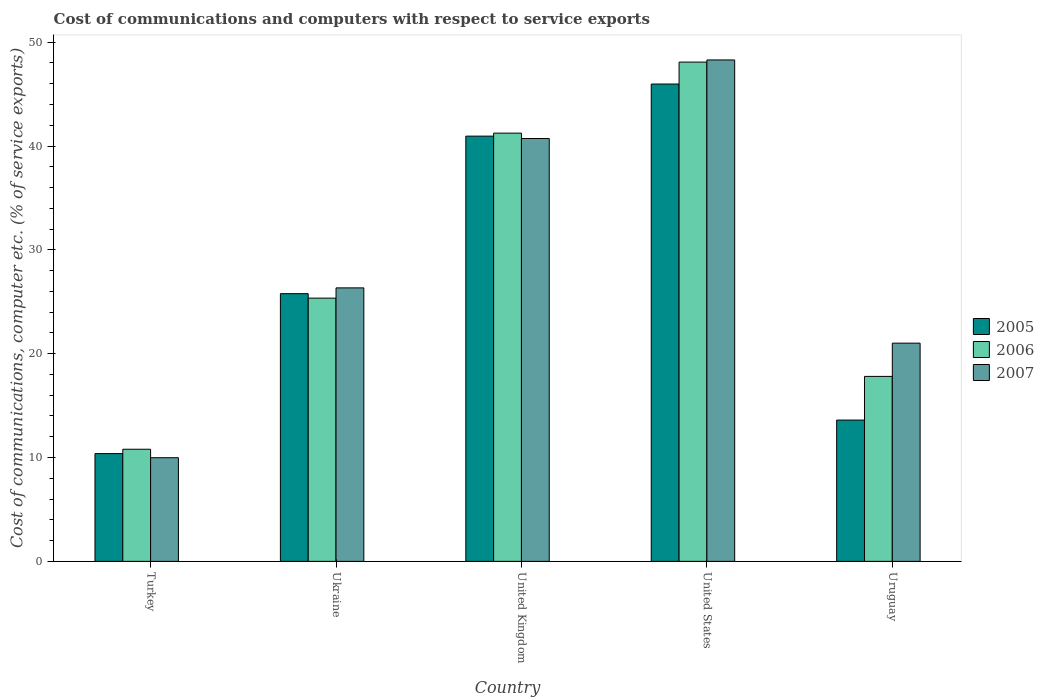How many different coloured bars are there?
Your answer should be very brief. 3. Are the number of bars per tick equal to the number of legend labels?
Your answer should be compact. Yes. How many bars are there on the 5th tick from the right?
Your answer should be compact. 3. What is the label of the 2nd group of bars from the left?
Make the answer very short. Ukraine. What is the cost of communications and computers in 2005 in Turkey?
Your answer should be compact. 10.38. Across all countries, what is the maximum cost of communications and computers in 2007?
Your answer should be very brief. 48.29. Across all countries, what is the minimum cost of communications and computers in 2007?
Offer a very short reply. 9.98. In which country was the cost of communications and computers in 2007 maximum?
Keep it short and to the point. United States. What is the total cost of communications and computers in 2006 in the graph?
Your answer should be very brief. 143.29. What is the difference between the cost of communications and computers in 2005 in Turkey and that in Ukraine?
Offer a very short reply. -15.4. What is the difference between the cost of communications and computers in 2005 in United Kingdom and the cost of communications and computers in 2006 in Uruguay?
Offer a terse response. 23.14. What is the average cost of communications and computers in 2005 per country?
Your answer should be compact. 27.34. What is the difference between the cost of communications and computers of/in 2006 and cost of communications and computers of/in 2007 in Ukraine?
Keep it short and to the point. -0.99. In how many countries, is the cost of communications and computers in 2006 greater than 12 %?
Your answer should be very brief. 4. What is the ratio of the cost of communications and computers in 2007 in Ukraine to that in Uruguay?
Keep it short and to the point. 1.25. Is the cost of communications and computers in 2005 in Turkey less than that in United Kingdom?
Give a very brief answer. Yes. What is the difference between the highest and the second highest cost of communications and computers in 2005?
Offer a very short reply. 15.17. What is the difference between the highest and the lowest cost of communications and computers in 2006?
Provide a short and direct response. 37.29. Are all the bars in the graph horizontal?
Your response must be concise. No. Are the values on the major ticks of Y-axis written in scientific E-notation?
Provide a short and direct response. No. Does the graph contain grids?
Your response must be concise. No. Where does the legend appear in the graph?
Make the answer very short. Center right. How many legend labels are there?
Make the answer very short. 3. How are the legend labels stacked?
Offer a terse response. Vertical. What is the title of the graph?
Ensure brevity in your answer.  Cost of communications and computers with respect to service exports. Does "1963" appear as one of the legend labels in the graph?
Your answer should be very brief. No. What is the label or title of the X-axis?
Provide a short and direct response. Country. What is the label or title of the Y-axis?
Your response must be concise. Cost of communications, computer etc. (% of service exports). What is the Cost of communications, computer etc. (% of service exports) in 2005 in Turkey?
Your response must be concise. 10.38. What is the Cost of communications, computer etc. (% of service exports) in 2006 in Turkey?
Offer a terse response. 10.8. What is the Cost of communications, computer etc. (% of service exports) of 2007 in Turkey?
Ensure brevity in your answer.  9.98. What is the Cost of communications, computer etc. (% of service exports) of 2005 in Ukraine?
Give a very brief answer. 25.78. What is the Cost of communications, computer etc. (% of service exports) in 2006 in Ukraine?
Give a very brief answer. 25.35. What is the Cost of communications, computer etc. (% of service exports) of 2007 in Ukraine?
Ensure brevity in your answer.  26.34. What is the Cost of communications, computer etc. (% of service exports) in 2005 in United Kingdom?
Provide a succinct answer. 40.95. What is the Cost of communications, computer etc. (% of service exports) in 2006 in United Kingdom?
Your answer should be compact. 41.24. What is the Cost of communications, computer etc. (% of service exports) of 2007 in United Kingdom?
Offer a terse response. 40.72. What is the Cost of communications, computer etc. (% of service exports) in 2005 in United States?
Offer a terse response. 45.97. What is the Cost of communications, computer etc. (% of service exports) of 2006 in United States?
Give a very brief answer. 48.08. What is the Cost of communications, computer etc. (% of service exports) of 2007 in United States?
Provide a succinct answer. 48.29. What is the Cost of communications, computer etc. (% of service exports) in 2005 in Uruguay?
Your answer should be very brief. 13.61. What is the Cost of communications, computer etc. (% of service exports) of 2006 in Uruguay?
Make the answer very short. 17.81. What is the Cost of communications, computer etc. (% of service exports) in 2007 in Uruguay?
Your response must be concise. 21.01. Across all countries, what is the maximum Cost of communications, computer etc. (% of service exports) in 2005?
Make the answer very short. 45.97. Across all countries, what is the maximum Cost of communications, computer etc. (% of service exports) in 2006?
Provide a succinct answer. 48.08. Across all countries, what is the maximum Cost of communications, computer etc. (% of service exports) in 2007?
Your answer should be compact. 48.29. Across all countries, what is the minimum Cost of communications, computer etc. (% of service exports) of 2005?
Your answer should be very brief. 10.38. Across all countries, what is the minimum Cost of communications, computer etc. (% of service exports) in 2006?
Give a very brief answer. 10.8. Across all countries, what is the minimum Cost of communications, computer etc. (% of service exports) in 2007?
Keep it short and to the point. 9.98. What is the total Cost of communications, computer etc. (% of service exports) in 2005 in the graph?
Your response must be concise. 136.69. What is the total Cost of communications, computer etc. (% of service exports) in 2006 in the graph?
Your answer should be very brief. 143.29. What is the total Cost of communications, computer etc. (% of service exports) in 2007 in the graph?
Your answer should be very brief. 146.35. What is the difference between the Cost of communications, computer etc. (% of service exports) in 2005 in Turkey and that in Ukraine?
Keep it short and to the point. -15.4. What is the difference between the Cost of communications, computer etc. (% of service exports) in 2006 in Turkey and that in Ukraine?
Offer a terse response. -14.55. What is the difference between the Cost of communications, computer etc. (% of service exports) of 2007 in Turkey and that in Ukraine?
Offer a very short reply. -16.36. What is the difference between the Cost of communications, computer etc. (% of service exports) of 2005 in Turkey and that in United Kingdom?
Your answer should be compact. -30.58. What is the difference between the Cost of communications, computer etc. (% of service exports) of 2006 in Turkey and that in United Kingdom?
Provide a succinct answer. -30.44. What is the difference between the Cost of communications, computer etc. (% of service exports) in 2007 in Turkey and that in United Kingdom?
Make the answer very short. -30.74. What is the difference between the Cost of communications, computer etc. (% of service exports) of 2005 in Turkey and that in United States?
Provide a short and direct response. -35.59. What is the difference between the Cost of communications, computer etc. (% of service exports) of 2006 in Turkey and that in United States?
Your answer should be very brief. -37.29. What is the difference between the Cost of communications, computer etc. (% of service exports) of 2007 in Turkey and that in United States?
Your answer should be very brief. -38.31. What is the difference between the Cost of communications, computer etc. (% of service exports) in 2005 in Turkey and that in Uruguay?
Your response must be concise. -3.23. What is the difference between the Cost of communications, computer etc. (% of service exports) of 2006 in Turkey and that in Uruguay?
Offer a terse response. -7.02. What is the difference between the Cost of communications, computer etc. (% of service exports) of 2007 in Turkey and that in Uruguay?
Keep it short and to the point. -11.03. What is the difference between the Cost of communications, computer etc. (% of service exports) in 2005 in Ukraine and that in United Kingdom?
Your answer should be compact. -15.17. What is the difference between the Cost of communications, computer etc. (% of service exports) of 2006 in Ukraine and that in United Kingdom?
Offer a very short reply. -15.89. What is the difference between the Cost of communications, computer etc. (% of service exports) of 2007 in Ukraine and that in United Kingdom?
Your answer should be very brief. -14.39. What is the difference between the Cost of communications, computer etc. (% of service exports) of 2005 in Ukraine and that in United States?
Your response must be concise. -20.19. What is the difference between the Cost of communications, computer etc. (% of service exports) in 2006 in Ukraine and that in United States?
Your answer should be very brief. -22.73. What is the difference between the Cost of communications, computer etc. (% of service exports) in 2007 in Ukraine and that in United States?
Your response must be concise. -21.95. What is the difference between the Cost of communications, computer etc. (% of service exports) in 2005 in Ukraine and that in Uruguay?
Your response must be concise. 12.17. What is the difference between the Cost of communications, computer etc. (% of service exports) in 2006 in Ukraine and that in Uruguay?
Give a very brief answer. 7.54. What is the difference between the Cost of communications, computer etc. (% of service exports) of 2007 in Ukraine and that in Uruguay?
Offer a terse response. 5.32. What is the difference between the Cost of communications, computer etc. (% of service exports) of 2005 in United Kingdom and that in United States?
Provide a short and direct response. -5.02. What is the difference between the Cost of communications, computer etc. (% of service exports) in 2006 in United Kingdom and that in United States?
Provide a succinct answer. -6.84. What is the difference between the Cost of communications, computer etc. (% of service exports) in 2007 in United Kingdom and that in United States?
Provide a short and direct response. -7.57. What is the difference between the Cost of communications, computer etc. (% of service exports) in 2005 in United Kingdom and that in Uruguay?
Your response must be concise. 27.34. What is the difference between the Cost of communications, computer etc. (% of service exports) in 2006 in United Kingdom and that in Uruguay?
Give a very brief answer. 23.43. What is the difference between the Cost of communications, computer etc. (% of service exports) of 2007 in United Kingdom and that in Uruguay?
Your response must be concise. 19.71. What is the difference between the Cost of communications, computer etc. (% of service exports) in 2005 in United States and that in Uruguay?
Your answer should be very brief. 32.36. What is the difference between the Cost of communications, computer etc. (% of service exports) of 2006 in United States and that in Uruguay?
Your answer should be very brief. 30.27. What is the difference between the Cost of communications, computer etc. (% of service exports) of 2007 in United States and that in Uruguay?
Give a very brief answer. 27.27. What is the difference between the Cost of communications, computer etc. (% of service exports) in 2005 in Turkey and the Cost of communications, computer etc. (% of service exports) in 2006 in Ukraine?
Offer a very short reply. -14.97. What is the difference between the Cost of communications, computer etc. (% of service exports) of 2005 in Turkey and the Cost of communications, computer etc. (% of service exports) of 2007 in Ukraine?
Offer a terse response. -15.96. What is the difference between the Cost of communications, computer etc. (% of service exports) of 2006 in Turkey and the Cost of communications, computer etc. (% of service exports) of 2007 in Ukraine?
Provide a succinct answer. -15.54. What is the difference between the Cost of communications, computer etc. (% of service exports) in 2005 in Turkey and the Cost of communications, computer etc. (% of service exports) in 2006 in United Kingdom?
Keep it short and to the point. -30.86. What is the difference between the Cost of communications, computer etc. (% of service exports) in 2005 in Turkey and the Cost of communications, computer etc. (% of service exports) in 2007 in United Kingdom?
Your response must be concise. -30.35. What is the difference between the Cost of communications, computer etc. (% of service exports) of 2006 in Turkey and the Cost of communications, computer etc. (% of service exports) of 2007 in United Kingdom?
Keep it short and to the point. -29.92. What is the difference between the Cost of communications, computer etc. (% of service exports) in 2005 in Turkey and the Cost of communications, computer etc. (% of service exports) in 2006 in United States?
Your answer should be compact. -37.71. What is the difference between the Cost of communications, computer etc. (% of service exports) in 2005 in Turkey and the Cost of communications, computer etc. (% of service exports) in 2007 in United States?
Offer a terse response. -37.91. What is the difference between the Cost of communications, computer etc. (% of service exports) in 2006 in Turkey and the Cost of communications, computer etc. (% of service exports) in 2007 in United States?
Offer a terse response. -37.49. What is the difference between the Cost of communications, computer etc. (% of service exports) in 2005 in Turkey and the Cost of communications, computer etc. (% of service exports) in 2006 in Uruguay?
Make the answer very short. -7.44. What is the difference between the Cost of communications, computer etc. (% of service exports) of 2005 in Turkey and the Cost of communications, computer etc. (% of service exports) of 2007 in Uruguay?
Ensure brevity in your answer.  -10.64. What is the difference between the Cost of communications, computer etc. (% of service exports) in 2006 in Turkey and the Cost of communications, computer etc. (% of service exports) in 2007 in Uruguay?
Offer a very short reply. -10.22. What is the difference between the Cost of communications, computer etc. (% of service exports) in 2005 in Ukraine and the Cost of communications, computer etc. (% of service exports) in 2006 in United Kingdom?
Offer a terse response. -15.46. What is the difference between the Cost of communications, computer etc. (% of service exports) in 2005 in Ukraine and the Cost of communications, computer etc. (% of service exports) in 2007 in United Kingdom?
Provide a succinct answer. -14.94. What is the difference between the Cost of communications, computer etc. (% of service exports) in 2006 in Ukraine and the Cost of communications, computer etc. (% of service exports) in 2007 in United Kingdom?
Provide a short and direct response. -15.37. What is the difference between the Cost of communications, computer etc. (% of service exports) in 2005 in Ukraine and the Cost of communications, computer etc. (% of service exports) in 2006 in United States?
Keep it short and to the point. -22.3. What is the difference between the Cost of communications, computer etc. (% of service exports) in 2005 in Ukraine and the Cost of communications, computer etc. (% of service exports) in 2007 in United States?
Ensure brevity in your answer.  -22.51. What is the difference between the Cost of communications, computer etc. (% of service exports) of 2006 in Ukraine and the Cost of communications, computer etc. (% of service exports) of 2007 in United States?
Your answer should be compact. -22.94. What is the difference between the Cost of communications, computer etc. (% of service exports) in 2005 in Ukraine and the Cost of communications, computer etc. (% of service exports) in 2006 in Uruguay?
Offer a very short reply. 7.97. What is the difference between the Cost of communications, computer etc. (% of service exports) in 2005 in Ukraine and the Cost of communications, computer etc. (% of service exports) in 2007 in Uruguay?
Give a very brief answer. 4.77. What is the difference between the Cost of communications, computer etc. (% of service exports) in 2006 in Ukraine and the Cost of communications, computer etc. (% of service exports) in 2007 in Uruguay?
Your answer should be compact. 4.34. What is the difference between the Cost of communications, computer etc. (% of service exports) of 2005 in United Kingdom and the Cost of communications, computer etc. (% of service exports) of 2006 in United States?
Provide a succinct answer. -7.13. What is the difference between the Cost of communications, computer etc. (% of service exports) of 2005 in United Kingdom and the Cost of communications, computer etc. (% of service exports) of 2007 in United States?
Give a very brief answer. -7.34. What is the difference between the Cost of communications, computer etc. (% of service exports) of 2006 in United Kingdom and the Cost of communications, computer etc. (% of service exports) of 2007 in United States?
Provide a succinct answer. -7.05. What is the difference between the Cost of communications, computer etc. (% of service exports) in 2005 in United Kingdom and the Cost of communications, computer etc. (% of service exports) in 2006 in Uruguay?
Offer a terse response. 23.14. What is the difference between the Cost of communications, computer etc. (% of service exports) in 2005 in United Kingdom and the Cost of communications, computer etc. (% of service exports) in 2007 in Uruguay?
Make the answer very short. 19.94. What is the difference between the Cost of communications, computer etc. (% of service exports) of 2006 in United Kingdom and the Cost of communications, computer etc. (% of service exports) of 2007 in Uruguay?
Keep it short and to the point. 20.23. What is the difference between the Cost of communications, computer etc. (% of service exports) of 2005 in United States and the Cost of communications, computer etc. (% of service exports) of 2006 in Uruguay?
Your response must be concise. 28.16. What is the difference between the Cost of communications, computer etc. (% of service exports) of 2005 in United States and the Cost of communications, computer etc. (% of service exports) of 2007 in Uruguay?
Your answer should be very brief. 24.96. What is the difference between the Cost of communications, computer etc. (% of service exports) of 2006 in United States and the Cost of communications, computer etc. (% of service exports) of 2007 in Uruguay?
Keep it short and to the point. 27.07. What is the average Cost of communications, computer etc. (% of service exports) in 2005 per country?
Your response must be concise. 27.34. What is the average Cost of communications, computer etc. (% of service exports) in 2006 per country?
Ensure brevity in your answer.  28.66. What is the average Cost of communications, computer etc. (% of service exports) of 2007 per country?
Your answer should be very brief. 29.27. What is the difference between the Cost of communications, computer etc. (% of service exports) of 2005 and Cost of communications, computer etc. (% of service exports) of 2006 in Turkey?
Your answer should be very brief. -0.42. What is the difference between the Cost of communications, computer etc. (% of service exports) in 2005 and Cost of communications, computer etc. (% of service exports) in 2007 in Turkey?
Ensure brevity in your answer.  0.39. What is the difference between the Cost of communications, computer etc. (% of service exports) in 2006 and Cost of communications, computer etc. (% of service exports) in 2007 in Turkey?
Make the answer very short. 0.82. What is the difference between the Cost of communications, computer etc. (% of service exports) of 2005 and Cost of communications, computer etc. (% of service exports) of 2006 in Ukraine?
Provide a succinct answer. 0.43. What is the difference between the Cost of communications, computer etc. (% of service exports) of 2005 and Cost of communications, computer etc. (% of service exports) of 2007 in Ukraine?
Ensure brevity in your answer.  -0.56. What is the difference between the Cost of communications, computer etc. (% of service exports) in 2006 and Cost of communications, computer etc. (% of service exports) in 2007 in Ukraine?
Your answer should be very brief. -0.99. What is the difference between the Cost of communications, computer etc. (% of service exports) in 2005 and Cost of communications, computer etc. (% of service exports) in 2006 in United Kingdom?
Give a very brief answer. -0.29. What is the difference between the Cost of communications, computer etc. (% of service exports) of 2005 and Cost of communications, computer etc. (% of service exports) of 2007 in United Kingdom?
Your answer should be compact. 0.23. What is the difference between the Cost of communications, computer etc. (% of service exports) of 2006 and Cost of communications, computer etc. (% of service exports) of 2007 in United Kingdom?
Ensure brevity in your answer.  0.52. What is the difference between the Cost of communications, computer etc. (% of service exports) in 2005 and Cost of communications, computer etc. (% of service exports) in 2006 in United States?
Your answer should be very brief. -2.11. What is the difference between the Cost of communications, computer etc. (% of service exports) of 2005 and Cost of communications, computer etc. (% of service exports) of 2007 in United States?
Provide a succinct answer. -2.32. What is the difference between the Cost of communications, computer etc. (% of service exports) of 2006 and Cost of communications, computer etc. (% of service exports) of 2007 in United States?
Offer a terse response. -0.21. What is the difference between the Cost of communications, computer etc. (% of service exports) in 2005 and Cost of communications, computer etc. (% of service exports) in 2006 in Uruguay?
Your answer should be very brief. -4.21. What is the difference between the Cost of communications, computer etc. (% of service exports) of 2005 and Cost of communications, computer etc. (% of service exports) of 2007 in Uruguay?
Provide a short and direct response. -7.41. What is the difference between the Cost of communications, computer etc. (% of service exports) of 2006 and Cost of communications, computer etc. (% of service exports) of 2007 in Uruguay?
Your response must be concise. -3.2. What is the ratio of the Cost of communications, computer etc. (% of service exports) of 2005 in Turkey to that in Ukraine?
Make the answer very short. 0.4. What is the ratio of the Cost of communications, computer etc. (% of service exports) in 2006 in Turkey to that in Ukraine?
Give a very brief answer. 0.43. What is the ratio of the Cost of communications, computer etc. (% of service exports) of 2007 in Turkey to that in Ukraine?
Offer a terse response. 0.38. What is the ratio of the Cost of communications, computer etc. (% of service exports) of 2005 in Turkey to that in United Kingdom?
Provide a succinct answer. 0.25. What is the ratio of the Cost of communications, computer etc. (% of service exports) in 2006 in Turkey to that in United Kingdom?
Offer a terse response. 0.26. What is the ratio of the Cost of communications, computer etc. (% of service exports) of 2007 in Turkey to that in United Kingdom?
Keep it short and to the point. 0.25. What is the ratio of the Cost of communications, computer etc. (% of service exports) in 2005 in Turkey to that in United States?
Offer a very short reply. 0.23. What is the ratio of the Cost of communications, computer etc. (% of service exports) of 2006 in Turkey to that in United States?
Your answer should be compact. 0.22. What is the ratio of the Cost of communications, computer etc. (% of service exports) of 2007 in Turkey to that in United States?
Offer a very short reply. 0.21. What is the ratio of the Cost of communications, computer etc. (% of service exports) of 2005 in Turkey to that in Uruguay?
Make the answer very short. 0.76. What is the ratio of the Cost of communications, computer etc. (% of service exports) in 2006 in Turkey to that in Uruguay?
Offer a terse response. 0.61. What is the ratio of the Cost of communications, computer etc. (% of service exports) of 2007 in Turkey to that in Uruguay?
Ensure brevity in your answer.  0.47. What is the ratio of the Cost of communications, computer etc. (% of service exports) in 2005 in Ukraine to that in United Kingdom?
Make the answer very short. 0.63. What is the ratio of the Cost of communications, computer etc. (% of service exports) in 2006 in Ukraine to that in United Kingdom?
Make the answer very short. 0.61. What is the ratio of the Cost of communications, computer etc. (% of service exports) of 2007 in Ukraine to that in United Kingdom?
Offer a terse response. 0.65. What is the ratio of the Cost of communications, computer etc. (% of service exports) in 2005 in Ukraine to that in United States?
Give a very brief answer. 0.56. What is the ratio of the Cost of communications, computer etc. (% of service exports) of 2006 in Ukraine to that in United States?
Offer a terse response. 0.53. What is the ratio of the Cost of communications, computer etc. (% of service exports) of 2007 in Ukraine to that in United States?
Your answer should be very brief. 0.55. What is the ratio of the Cost of communications, computer etc. (% of service exports) in 2005 in Ukraine to that in Uruguay?
Your answer should be very brief. 1.89. What is the ratio of the Cost of communications, computer etc. (% of service exports) in 2006 in Ukraine to that in Uruguay?
Keep it short and to the point. 1.42. What is the ratio of the Cost of communications, computer etc. (% of service exports) in 2007 in Ukraine to that in Uruguay?
Offer a very short reply. 1.25. What is the ratio of the Cost of communications, computer etc. (% of service exports) of 2005 in United Kingdom to that in United States?
Offer a very short reply. 0.89. What is the ratio of the Cost of communications, computer etc. (% of service exports) of 2006 in United Kingdom to that in United States?
Give a very brief answer. 0.86. What is the ratio of the Cost of communications, computer etc. (% of service exports) in 2007 in United Kingdom to that in United States?
Provide a succinct answer. 0.84. What is the ratio of the Cost of communications, computer etc. (% of service exports) in 2005 in United Kingdom to that in Uruguay?
Your response must be concise. 3.01. What is the ratio of the Cost of communications, computer etc. (% of service exports) of 2006 in United Kingdom to that in Uruguay?
Make the answer very short. 2.32. What is the ratio of the Cost of communications, computer etc. (% of service exports) in 2007 in United Kingdom to that in Uruguay?
Keep it short and to the point. 1.94. What is the ratio of the Cost of communications, computer etc. (% of service exports) of 2005 in United States to that in Uruguay?
Keep it short and to the point. 3.38. What is the ratio of the Cost of communications, computer etc. (% of service exports) in 2006 in United States to that in Uruguay?
Offer a very short reply. 2.7. What is the ratio of the Cost of communications, computer etc. (% of service exports) of 2007 in United States to that in Uruguay?
Provide a short and direct response. 2.3. What is the difference between the highest and the second highest Cost of communications, computer etc. (% of service exports) in 2005?
Keep it short and to the point. 5.02. What is the difference between the highest and the second highest Cost of communications, computer etc. (% of service exports) of 2006?
Offer a terse response. 6.84. What is the difference between the highest and the second highest Cost of communications, computer etc. (% of service exports) in 2007?
Make the answer very short. 7.57. What is the difference between the highest and the lowest Cost of communications, computer etc. (% of service exports) in 2005?
Your answer should be compact. 35.59. What is the difference between the highest and the lowest Cost of communications, computer etc. (% of service exports) of 2006?
Ensure brevity in your answer.  37.29. What is the difference between the highest and the lowest Cost of communications, computer etc. (% of service exports) of 2007?
Provide a succinct answer. 38.31. 